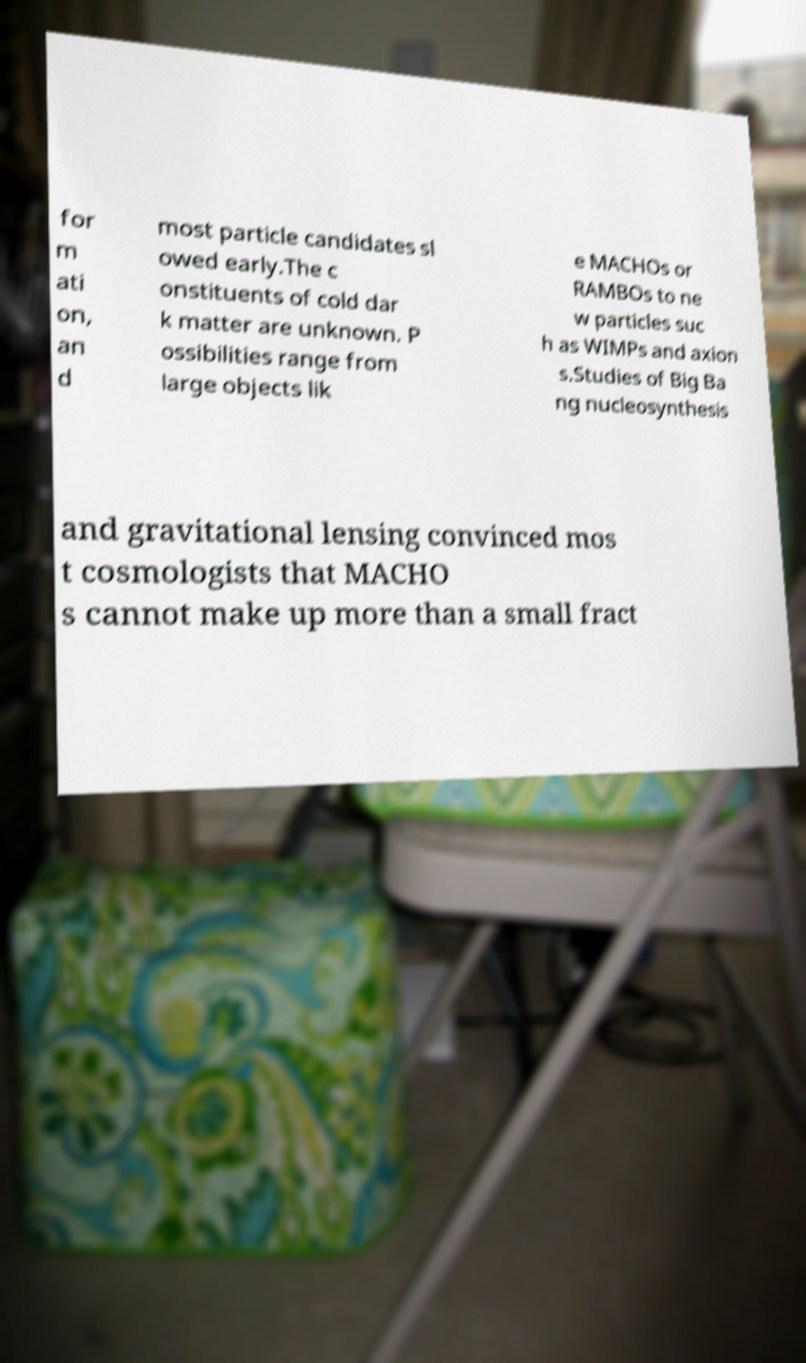Can you read and provide the text displayed in the image?This photo seems to have some interesting text. Can you extract and type it out for me? for m ati on, an d most particle candidates sl owed early.The c onstituents of cold dar k matter are unknown. P ossibilities range from large objects lik e MACHOs or RAMBOs to ne w particles suc h as WIMPs and axion s.Studies of Big Ba ng nucleosynthesis and gravitational lensing convinced mos t cosmologists that MACHO s cannot make up more than a small fract 